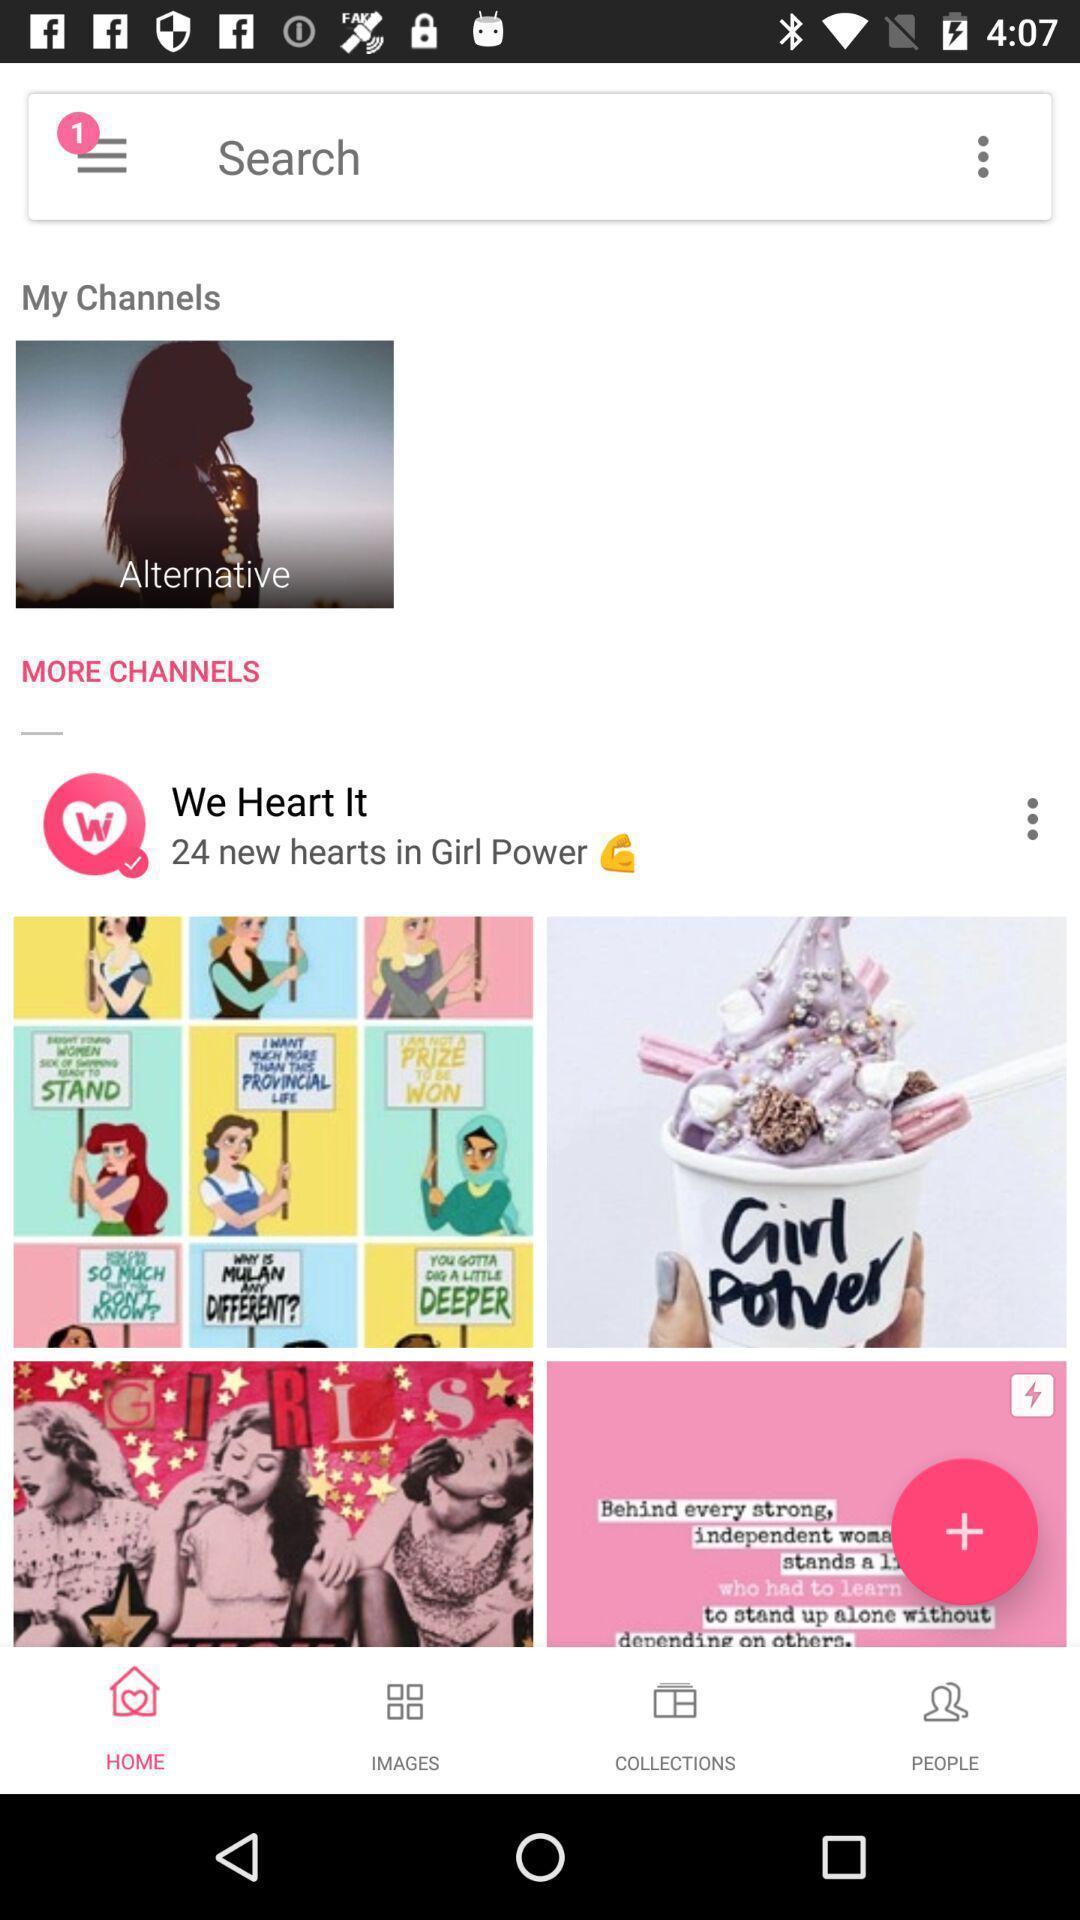What can you discern from this picture? Various images in the channel with quotations. 